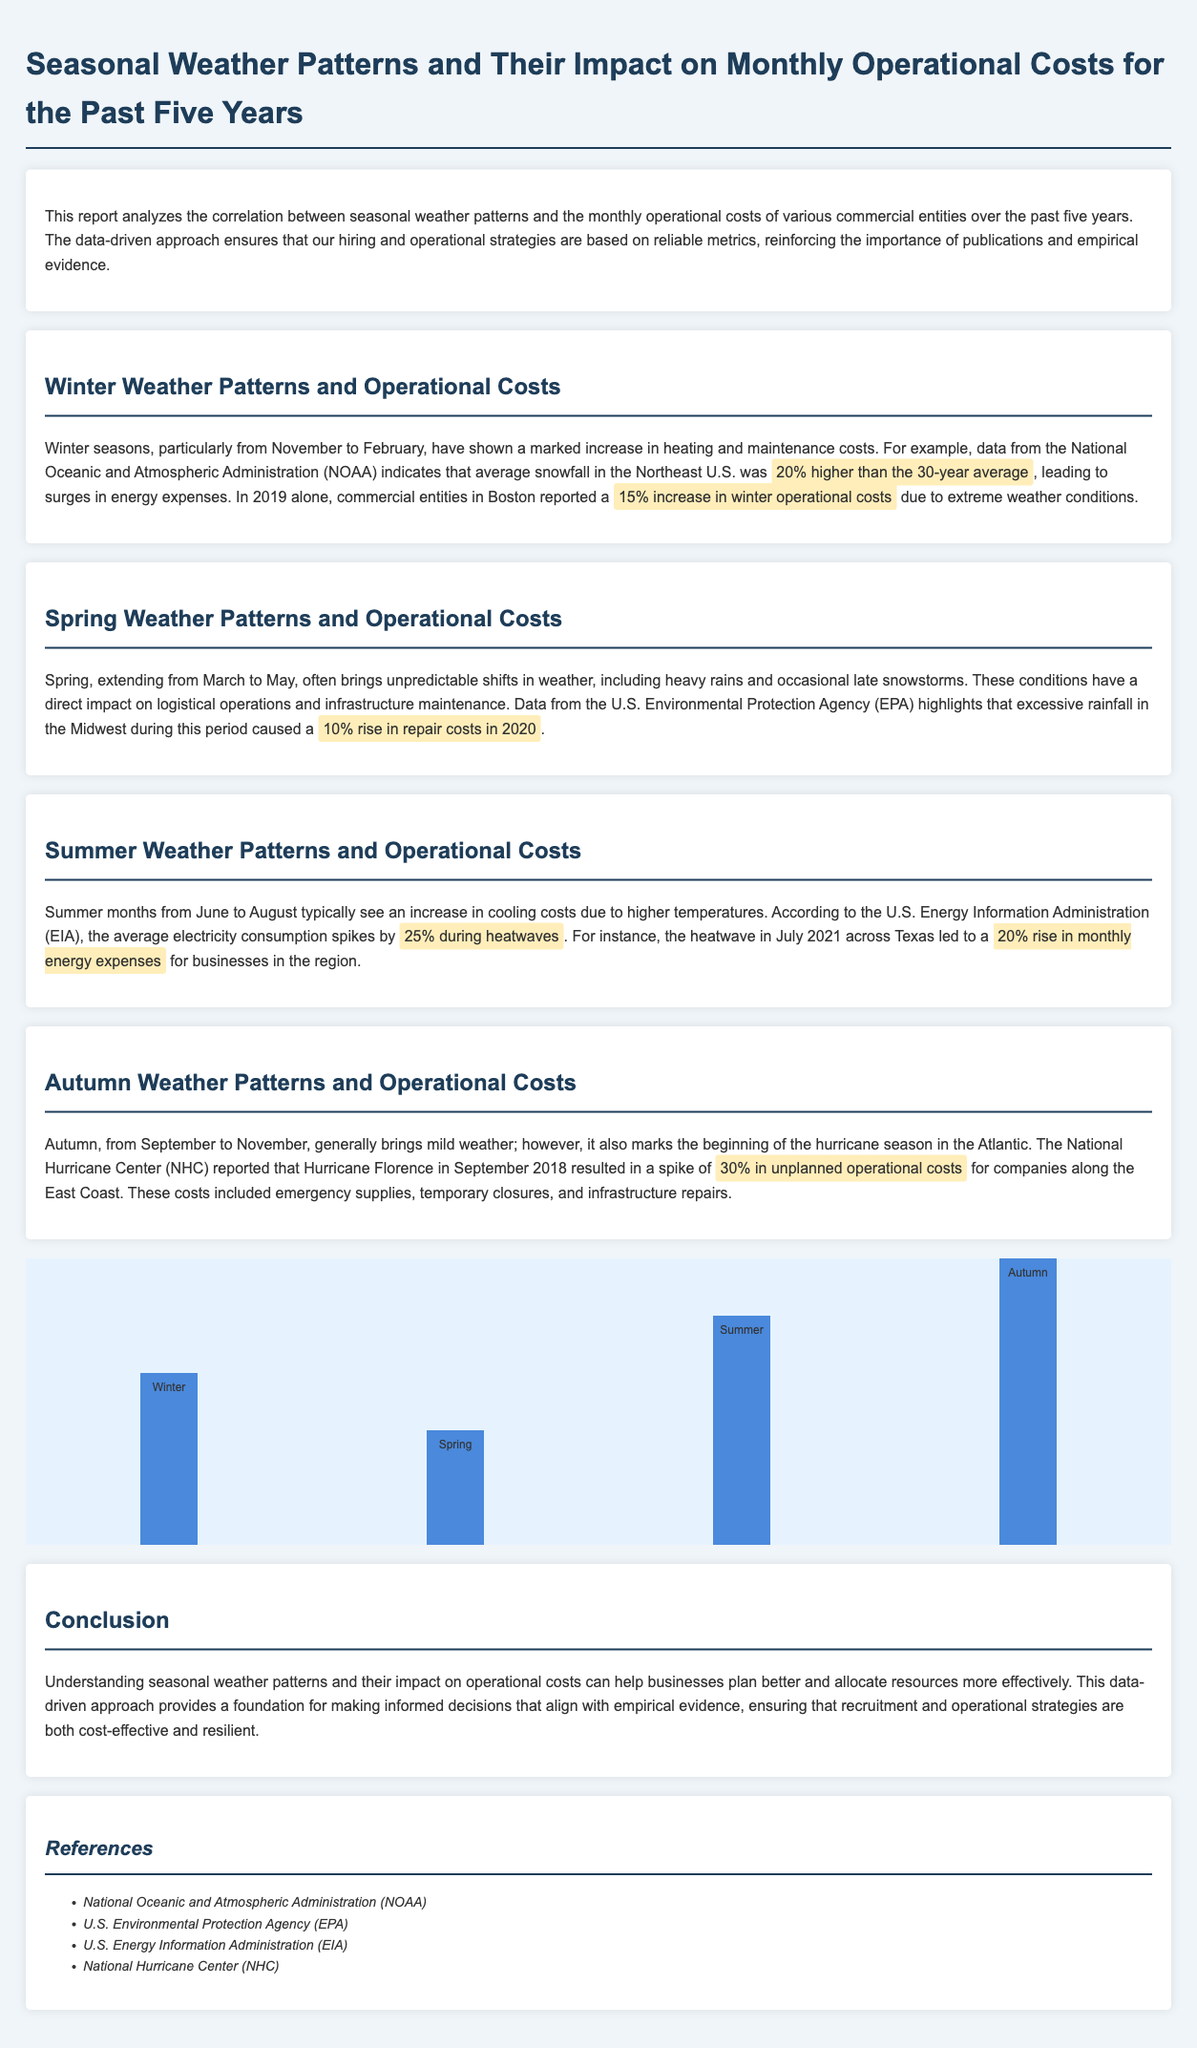what was the percentage increase in winter operational costs in 2019? The document states that in 2019, commercial entities in Boston reported a 15% increase in winter operational costs due to extreme weather conditions.
Answer: 15% what percentage higher was the average snowfall in the Northeast U.S. compared to the 30-year average? The report indicates that average snowfall in the Northeast U.S. was 20% higher than the 30-year average.
Answer: 20% which agency reported a 10% rise in repair costs in 2020 due to excessive rainfall? The U.S. Environmental Protection Agency (EPA) is the agency that highlighted the 10% rise in repair costs in 2020.
Answer: U.S. Environmental Protection Agency (EPA) what percentage rise in energy expenses did businesses face in Texas during the heatwave in July 2021? According to the document, businesses in Texas faced a 20% rise in monthly energy expenses during the heatwave in July 2021.
Answer: 20% what impact did Hurricane Florence have on operational costs in September 2018? The report states that Hurricane Florence resulted in a spike of 30% in unplanned operational costs for companies along the East Coast.
Answer: 30% what is the main purpose of the report? The main purpose of the report is to analyze the correlation between seasonal weather patterns and the monthly operational costs of various commercial entities.
Answer: Analyze correlation how many years does the report cover? The report covers seasonal weather patterns and their impact for the past five years.
Answer: Five years which season showed the highest operational cost in the chart? The chart indicates that autumn has the highest operational cost among the seasons analyzed.
Answer: Autumn what is the average electricity consumption spike during heatwaves according to the U.S. Energy Information Administration? The U.S. Energy Information Administration reports that average electricity consumption spikes by 25% during heatwaves.
Answer: 25% 